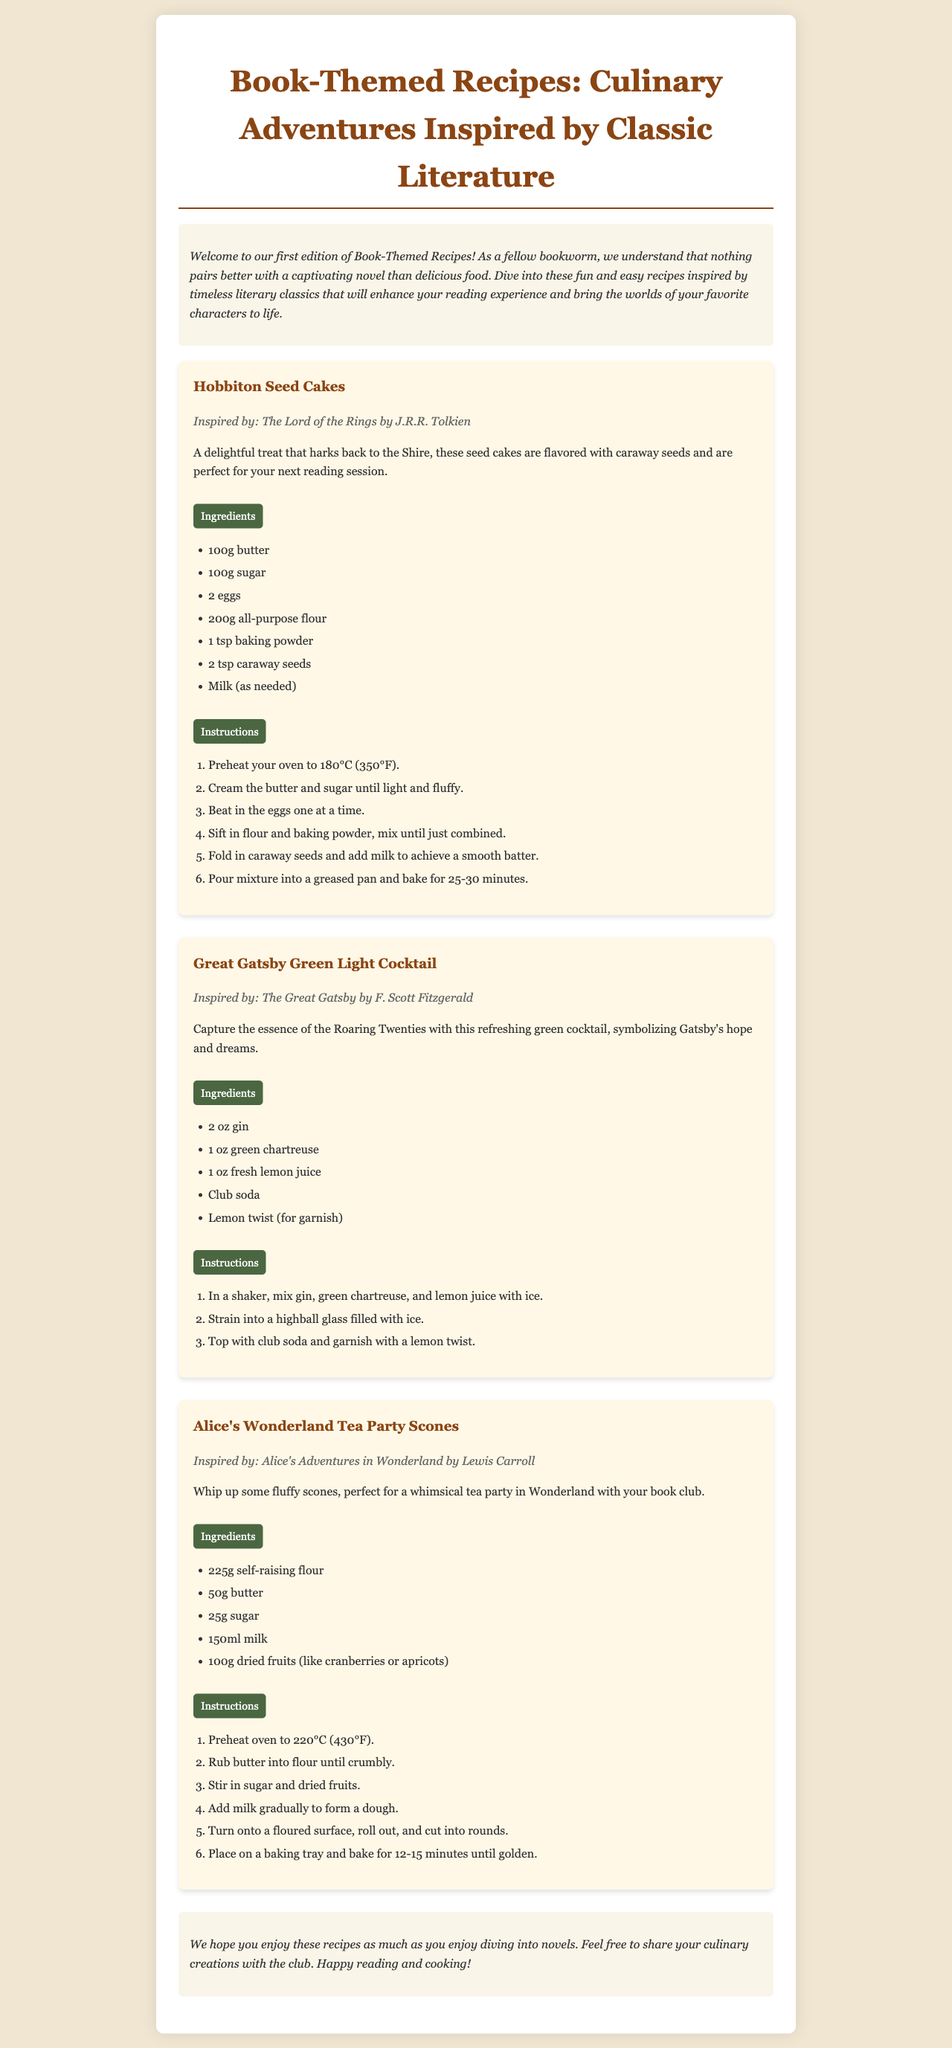What is the title of the newsletter? The title appears prominently at the top of the document, stating the theme of the newsletter.
Answer: Book-Themed Recipes: Culinary Adventures Inspired by Classic Literature What is one ingredient in Hobbiton Seed Cakes? The ingredients for each recipe are listed clearly, making it easy to identify them.
Answer: Caraway seeds Which cocktail is inspired by The Great Gatsby? The recipes clearly indicate the literary source of inspiration among the ingredients.
Answer: Great Gatsby Green Light Cocktail What temperature do you preheat the oven for Alice's Wonderland Tea Party Scones? Specific temperatures for baking are provided in the instructions for each recipe.
Answer: 220°C How many eggs are needed for Hobbiton Seed Cakes? Each recipe includes a list of ingredients, allowing for easy reference of quantities required.
Answer: 2 eggs What is the primary purpose of the newsletter? The introduction states the general intention of the document and its content.
Answer: To share recipes inspired by literature What type of food is featured in the newsletter? The newsletter focuses on a specific category of culinary creations derived from literary works.
Answer: Recipes In which section is the recipe for Great Gatsby Green Light Cocktail found? The structure of the document includes sections for each recipe, indicated by headings.
Answer: Recipe section 